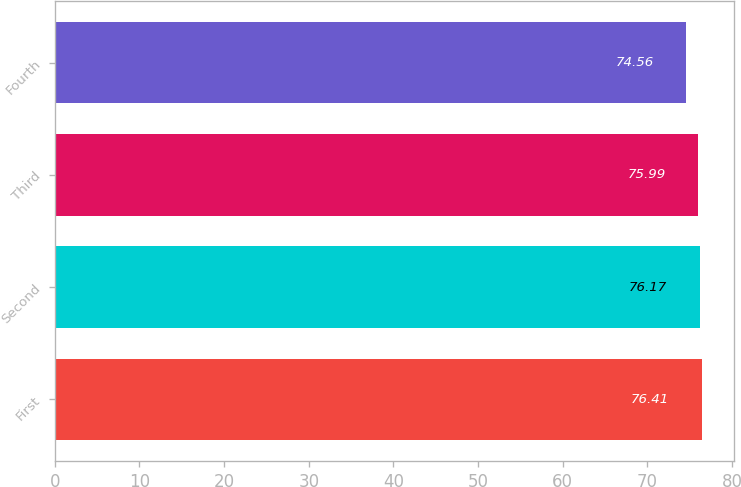<chart> <loc_0><loc_0><loc_500><loc_500><bar_chart><fcel>First<fcel>Second<fcel>Third<fcel>Fourth<nl><fcel>76.41<fcel>76.17<fcel>75.99<fcel>74.56<nl></chart> 